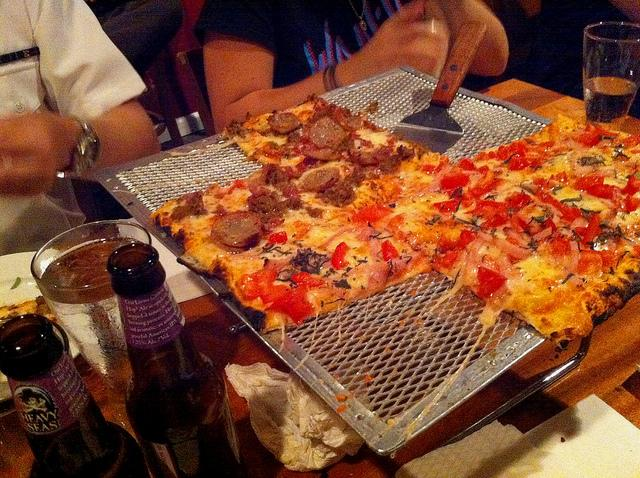What is the topping shown? sausage 